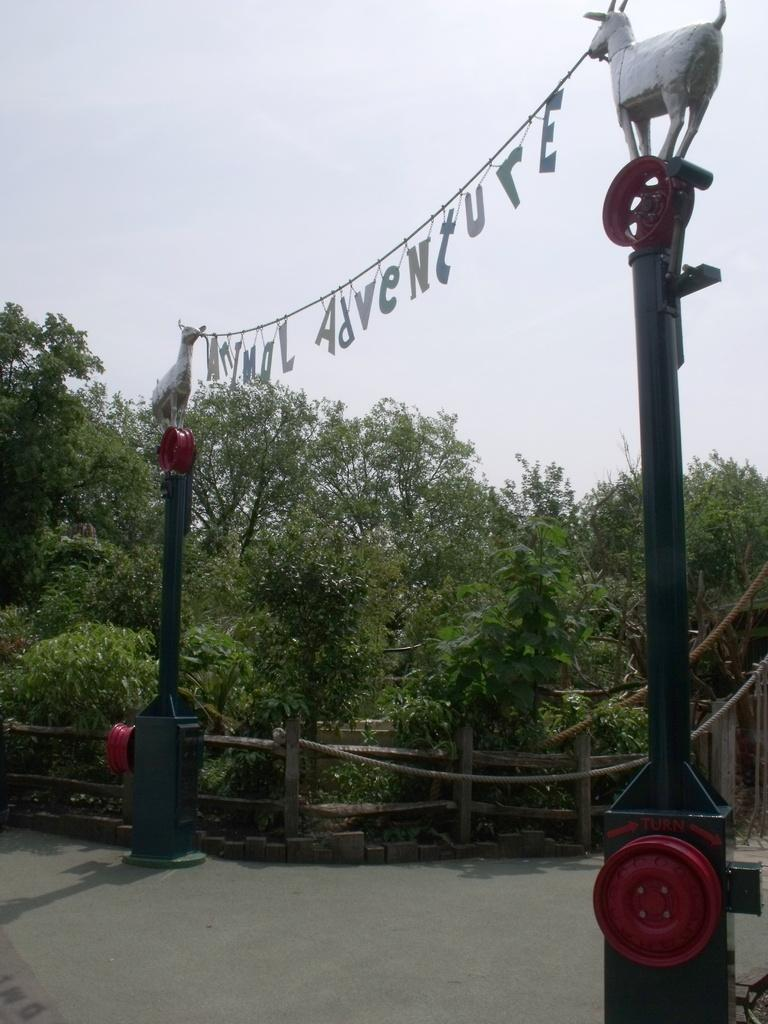What type of structures can be seen in the image? There are poles in the image. What natural elements are present in the image? There are trees in the image. What type of barrier can be seen in the image? There is a wooden fence in the image. What type of artistic objects are in the image? There are sculptures in the image. What type of cakes can be seen on the poles in the image? There are no cakes present in the image; it features poles, trees, a wooden fence, and sculptures. How does the grip of the trees change throughout the night in the image? The image does not depict a change in the grip of the trees throughout the night, as it does not show any time progression or nighttime setting. 